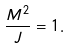Convert formula to latex. <formula><loc_0><loc_0><loc_500><loc_500>\frac { M ^ { 2 } } { J } = 1 .</formula> 